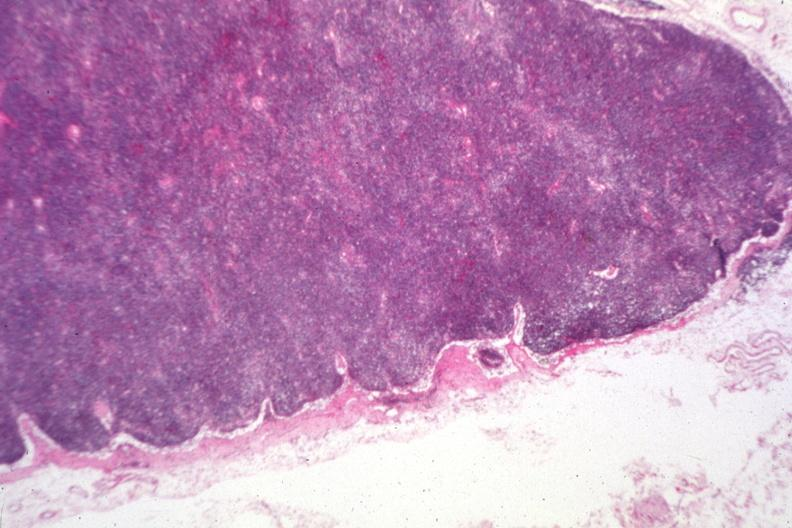s bone, calvarium present?
Answer the question using a single word or phrase. No 